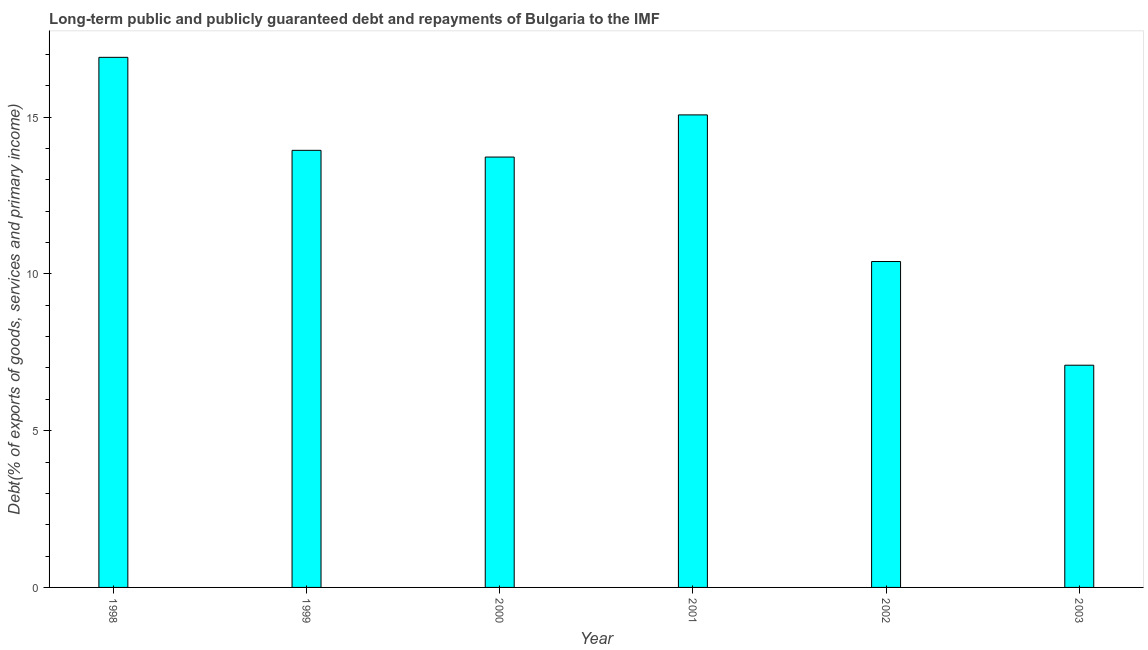Does the graph contain grids?
Your answer should be compact. No. What is the title of the graph?
Give a very brief answer. Long-term public and publicly guaranteed debt and repayments of Bulgaria to the IMF. What is the label or title of the X-axis?
Make the answer very short. Year. What is the label or title of the Y-axis?
Keep it short and to the point. Debt(% of exports of goods, services and primary income). What is the debt service in 2003?
Your answer should be very brief. 7.09. Across all years, what is the maximum debt service?
Provide a short and direct response. 16.91. Across all years, what is the minimum debt service?
Your answer should be very brief. 7.09. What is the sum of the debt service?
Your answer should be compact. 77.14. What is the difference between the debt service in 1998 and 2000?
Offer a terse response. 3.18. What is the average debt service per year?
Give a very brief answer. 12.86. What is the median debt service?
Your response must be concise. 13.84. In how many years, is the debt service greater than 13 %?
Provide a succinct answer. 4. What is the ratio of the debt service in 1998 to that in 2002?
Keep it short and to the point. 1.63. Is the debt service in 2000 less than that in 2002?
Offer a very short reply. No. Is the difference between the debt service in 1998 and 2000 greater than the difference between any two years?
Your answer should be compact. No. What is the difference between the highest and the second highest debt service?
Provide a short and direct response. 1.84. Is the sum of the debt service in 1999 and 2003 greater than the maximum debt service across all years?
Your answer should be compact. Yes. What is the difference between the highest and the lowest debt service?
Offer a terse response. 9.82. In how many years, is the debt service greater than the average debt service taken over all years?
Offer a terse response. 4. How many bars are there?
Provide a short and direct response. 6. Are all the bars in the graph horizontal?
Make the answer very short. No. How many years are there in the graph?
Provide a short and direct response. 6. What is the difference between two consecutive major ticks on the Y-axis?
Your answer should be compact. 5. Are the values on the major ticks of Y-axis written in scientific E-notation?
Your answer should be very brief. No. What is the Debt(% of exports of goods, services and primary income) in 1998?
Keep it short and to the point. 16.91. What is the Debt(% of exports of goods, services and primary income) in 1999?
Keep it short and to the point. 13.94. What is the Debt(% of exports of goods, services and primary income) of 2000?
Provide a short and direct response. 13.73. What is the Debt(% of exports of goods, services and primary income) of 2001?
Provide a short and direct response. 15.07. What is the Debt(% of exports of goods, services and primary income) in 2002?
Offer a terse response. 10.4. What is the Debt(% of exports of goods, services and primary income) of 2003?
Offer a terse response. 7.09. What is the difference between the Debt(% of exports of goods, services and primary income) in 1998 and 1999?
Make the answer very short. 2.97. What is the difference between the Debt(% of exports of goods, services and primary income) in 1998 and 2000?
Keep it short and to the point. 3.18. What is the difference between the Debt(% of exports of goods, services and primary income) in 1998 and 2001?
Keep it short and to the point. 1.84. What is the difference between the Debt(% of exports of goods, services and primary income) in 1998 and 2002?
Give a very brief answer. 6.51. What is the difference between the Debt(% of exports of goods, services and primary income) in 1998 and 2003?
Give a very brief answer. 9.82. What is the difference between the Debt(% of exports of goods, services and primary income) in 1999 and 2000?
Keep it short and to the point. 0.21. What is the difference between the Debt(% of exports of goods, services and primary income) in 1999 and 2001?
Your response must be concise. -1.13. What is the difference between the Debt(% of exports of goods, services and primary income) in 1999 and 2002?
Keep it short and to the point. 3.55. What is the difference between the Debt(% of exports of goods, services and primary income) in 1999 and 2003?
Give a very brief answer. 6.85. What is the difference between the Debt(% of exports of goods, services and primary income) in 2000 and 2001?
Ensure brevity in your answer.  -1.34. What is the difference between the Debt(% of exports of goods, services and primary income) in 2000 and 2002?
Provide a succinct answer. 3.33. What is the difference between the Debt(% of exports of goods, services and primary income) in 2000 and 2003?
Offer a terse response. 6.64. What is the difference between the Debt(% of exports of goods, services and primary income) in 2001 and 2002?
Give a very brief answer. 4.68. What is the difference between the Debt(% of exports of goods, services and primary income) in 2001 and 2003?
Offer a terse response. 7.98. What is the difference between the Debt(% of exports of goods, services and primary income) in 2002 and 2003?
Ensure brevity in your answer.  3.31. What is the ratio of the Debt(% of exports of goods, services and primary income) in 1998 to that in 1999?
Offer a terse response. 1.21. What is the ratio of the Debt(% of exports of goods, services and primary income) in 1998 to that in 2000?
Give a very brief answer. 1.23. What is the ratio of the Debt(% of exports of goods, services and primary income) in 1998 to that in 2001?
Provide a short and direct response. 1.12. What is the ratio of the Debt(% of exports of goods, services and primary income) in 1998 to that in 2002?
Provide a short and direct response. 1.63. What is the ratio of the Debt(% of exports of goods, services and primary income) in 1998 to that in 2003?
Provide a short and direct response. 2.39. What is the ratio of the Debt(% of exports of goods, services and primary income) in 1999 to that in 2000?
Provide a short and direct response. 1.02. What is the ratio of the Debt(% of exports of goods, services and primary income) in 1999 to that in 2001?
Your answer should be very brief. 0.93. What is the ratio of the Debt(% of exports of goods, services and primary income) in 1999 to that in 2002?
Ensure brevity in your answer.  1.34. What is the ratio of the Debt(% of exports of goods, services and primary income) in 1999 to that in 2003?
Your response must be concise. 1.97. What is the ratio of the Debt(% of exports of goods, services and primary income) in 2000 to that in 2001?
Give a very brief answer. 0.91. What is the ratio of the Debt(% of exports of goods, services and primary income) in 2000 to that in 2002?
Your response must be concise. 1.32. What is the ratio of the Debt(% of exports of goods, services and primary income) in 2000 to that in 2003?
Your response must be concise. 1.94. What is the ratio of the Debt(% of exports of goods, services and primary income) in 2001 to that in 2002?
Provide a succinct answer. 1.45. What is the ratio of the Debt(% of exports of goods, services and primary income) in 2001 to that in 2003?
Your answer should be very brief. 2.13. What is the ratio of the Debt(% of exports of goods, services and primary income) in 2002 to that in 2003?
Provide a short and direct response. 1.47. 